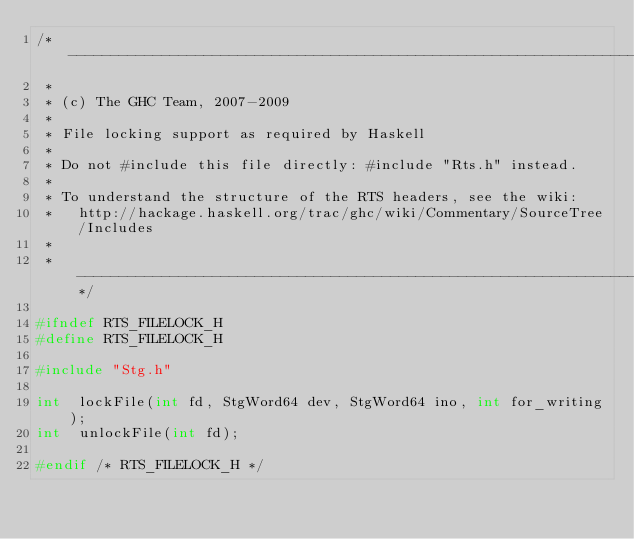Convert code to text. <code><loc_0><loc_0><loc_500><loc_500><_C_>/* -----------------------------------------------------------------------------
 *
 * (c) The GHC Team, 2007-2009
 *
 * File locking support as required by Haskell
 *
 * Do not #include this file directly: #include "Rts.h" instead.
 *
 * To understand the structure of the RTS headers, see the wiki:
 *   http://hackage.haskell.org/trac/ghc/wiki/Commentary/SourceTree/Includes
 *
 * ---------------------------------------------------------------------------*/

#ifndef RTS_FILELOCK_H
#define RTS_FILELOCK_H

#include "Stg.h"

int  lockFile(int fd, StgWord64 dev, StgWord64 ino, int for_writing);
int  unlockFile(int fd);

#endif /* RTS_FILELOCK_H */
</code> 